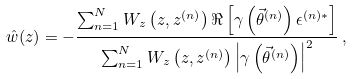<formula> <loc_0><loc_0><loc_500><loc_500>\hat { w } ( z ) = - \frac { \sum _ { n = 1 } ^ { N } W _ { z } \left ( z , z ^ { ( n ) } \right ) \Re \left [ \gamma \left ( \vec { \theta } ^ { ( n ) } \right ) \epsilon ^ { ( n ) * } \right ] } { \sum _ { n = 1 } ^ { N } W _ { z } \left ( z , z ^ { ( n ) } \right ) \left | \gamma \left ( \vec { \theta } ^ { ( n ) } \right ) \right | ^ { 2 } } \, ,</formula> 